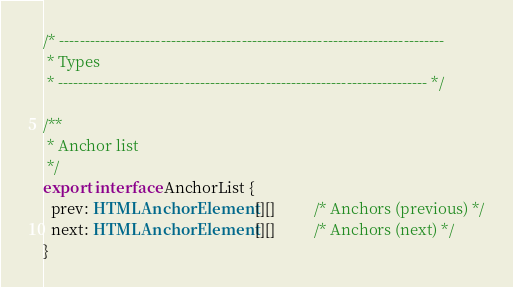<code> <loc_0><loc_0><loc_500><loc_500><_TypeScript_>
/* ----------------------------------------------------------------------------
 * Types
 * ------------------------------------------------------------------------- */

/**
 * Anchor list
 */
export interface AnchorList {
  prev: HTMLAnchorElement[][]          /* Anchors (previous) */
  next: HTMLAnchorElement[][]          /* Anchors (next) */
}
</code> 